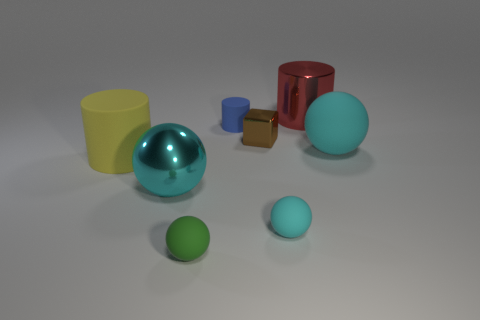There is a tiny matte object that is the same color as the large metal ball; what is its shape?
Your answer should be very brief. Sphere. Are there the same number of blue things that are behind the cyan metal sphere and cyan matte cylinders?
Your answer should be compact. No. How many cyan things are there?
Your answer should be very brief. 3. What is the shape of the rubber object that is both to the left of the red metal cylinder and on the right side of the blue matte object?
Keep it short and to the point. Sphere. Does the cylinder in front of the large cyan matte thing have the same color as the small rubber thing that is behind the small metallic object?
Offer a terse response. No. There is a metal sphere that is the same color as the big rubber ball; what size is it?
Your answer should be compact. Large. Are there any cyan spheres made of the same material as the tiny cyan thing?
Offer a terse response. Yes. Are there an equal number of small green objects on the right side of the large red shiny cylinder and small cyan matte balls that are on the right side of the small cyan object?
Your answer should be very brief. Yes. What size is the ball on the right side of the large red object?
Ensure brevity in your answer.  Large. What is the material of the small sphere right of the small matte sphere that is left of the small cyan matte thing?
Your response must be concise. Rubber. 